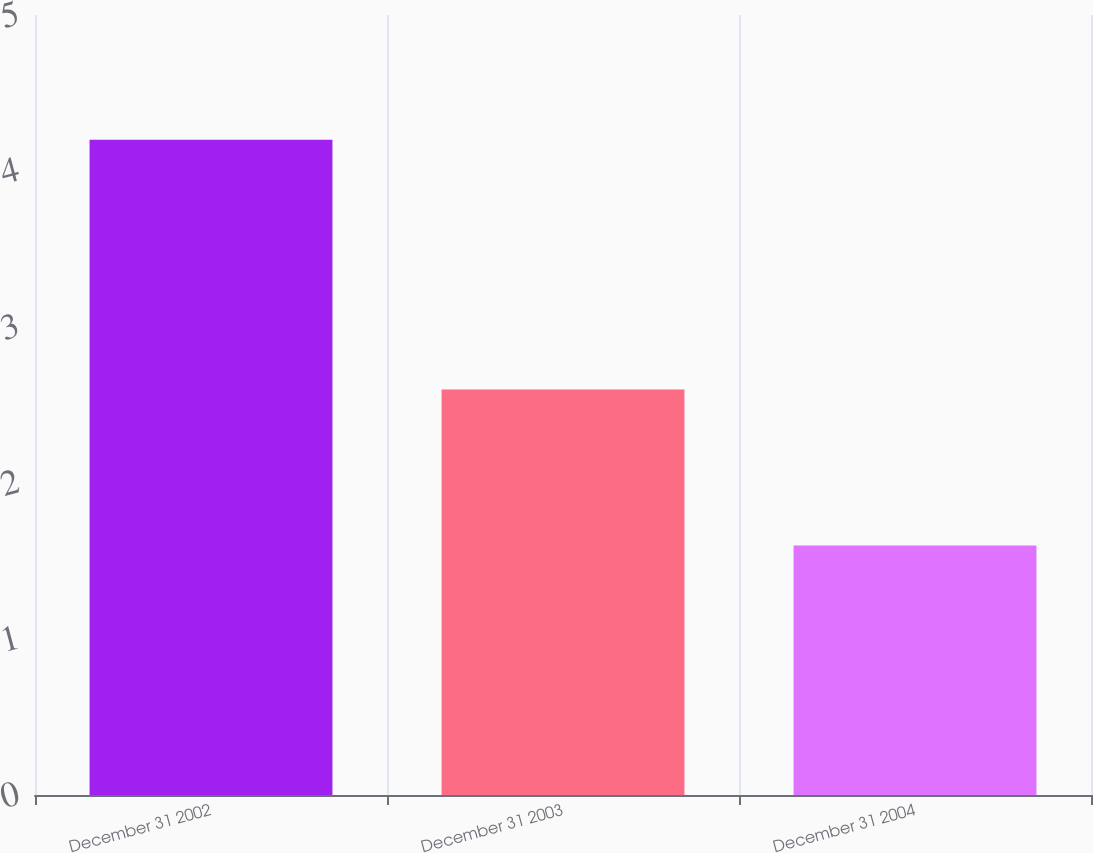Convert chart. <chart><loc_0><loc_0><loc_500><loc_500><bar_chart><fcel>December 31 2002<fcel>December 31 2003<fcel>December 31 2004<nl><fcel>4.2<fcel>2.6<fcel>1.6<nl></chart> 